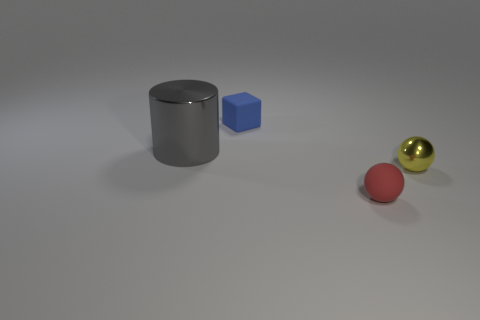Add 2 yellow rubber cubes. How many objects exist? 6 Subtract all red spheres. How many spheres are left? 1 Subtract all blocks. How many objects are left? 3 Subtract 0 yellow cylinders. How many objects are left? 4 Subtract 1 blocks. How many blocks are left? 0 Subtract all gray spheres. Subtract all blue blocks. How many spheres are left? 2 Subtract all red balls. How many purple cylinders are left? 0 Subtract all small metallic cylinders. Subtract all blue matte cubes. How many objects are left? 3 Add 4 large metal cylinders. How many large metal cylinders are left? 5 Add 1 tiny yellow shiny balls. How many tiny yellow shiny balls exist? 2 